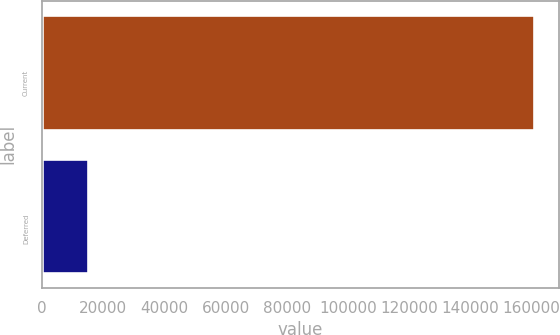Convert chart to OTSL. <chart><loc_0><loc_0><loc_500><loc_500><bar_chart><fcel>Current<fcel>Deferred<nl><fcel>160858<fcel>14903<nl></chart> 